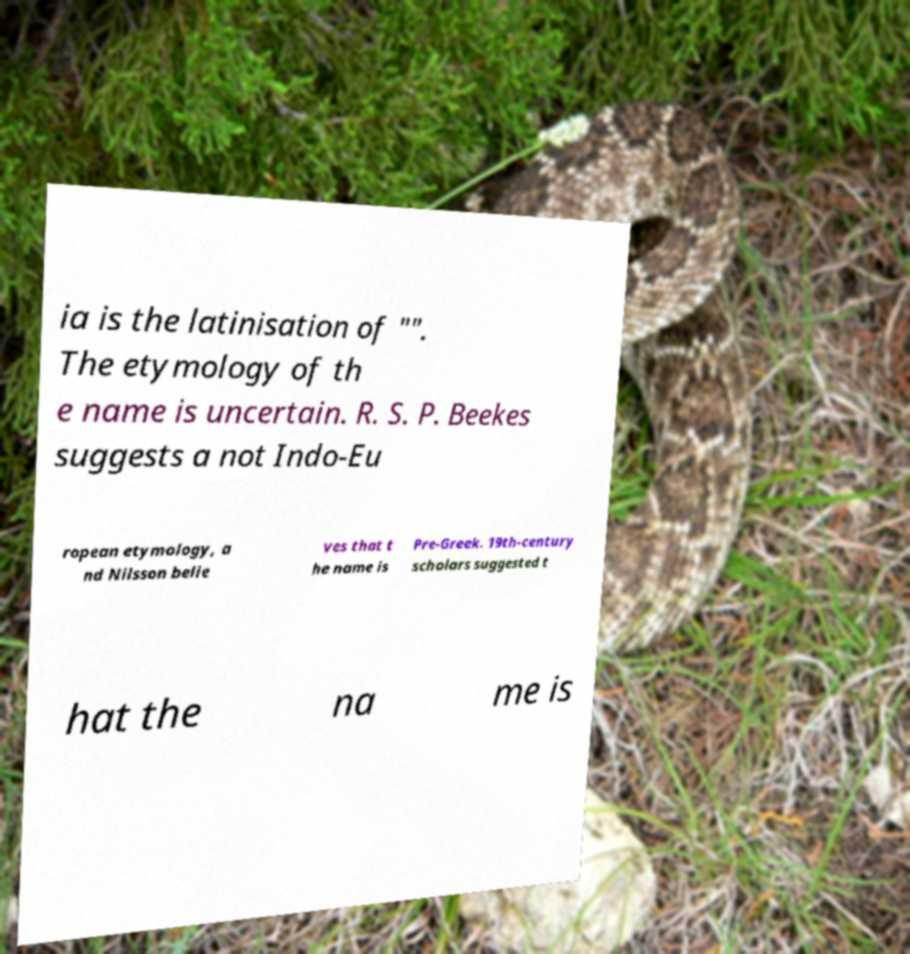What messages or text are displayed in this image? I need them in a readable, typed format. ia is the latinisation of "". The etymology of th e name is uncertain. R. S. P. Beekes suggests a not Indo-Eu ropean etymology, a nd Nilsson belie ves that t he name is Pre-Greek. 19th-century scholars suggested t hat the na me is 